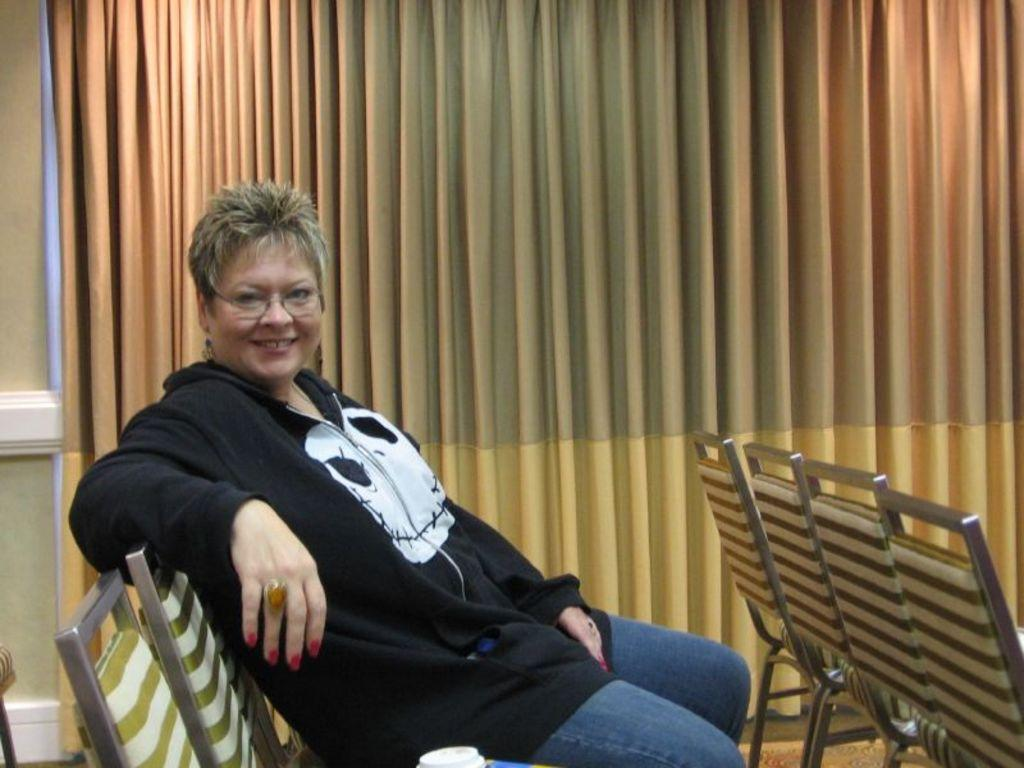Who is present in the image? There is a woman in the image. What is the woman wearing? The woman is wearing a black t-shirt. What is the woman's position in the image? The woman is sitting on a chair. What can be seen in the background of the image? There are curtains in the background of the image. What type of boat can be seen in the image? There is no boat present in the image. How does the taste of the woman's t-shirt compare to that of a lemon? The taste of the woman's t-shirt cannot be determined, as it is not a food item. 